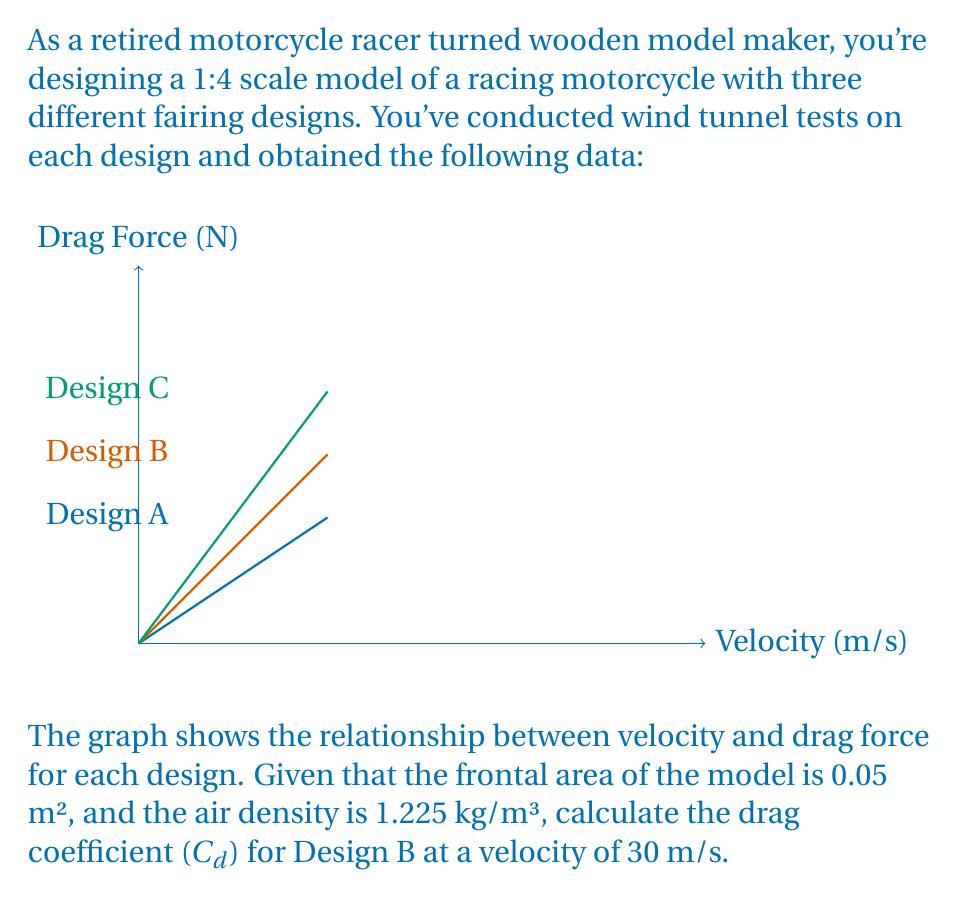Solve this math problem. To solve this problem, we'll use the drag equation:

$$F_d = \frac{1}{2} \rho v^2 C_d A$$

Where:
$F_d$ = Drag force (N)
$\rho$ = Air density (kg/m³)
$v$ = Velocity (m/s)
$C_d$ = Drag coefficient
$A$ = Frontal area (m²)

Steps to solve:

1. From the graph, we can see that for Design B at 30 m/s, the drag force is approximately 15 N.

2. We know:
   $F_d = 15$ N
   $\rho = 1.225$ kg/m³
   $v = 30$ m/s
   $A = 0.05$ m²

3. Substitute these values into the drag equation:

   $$15 = \frac{1}{2} \cdot 1.225 \cdot 30^2 \cdot C_d \cdot 0.05$$

4. Simplify:

   $$15 = 27.5625 \cdot C_d$$

5. Solve for $C_d$:

   $$C_d = \frac{15}{27.5625} \approx 0.544$$

Therefore, the drag coefficient for Design B at 30 m/s is approximately 0.544.
Answer: $C_d \approx 0.544$ 